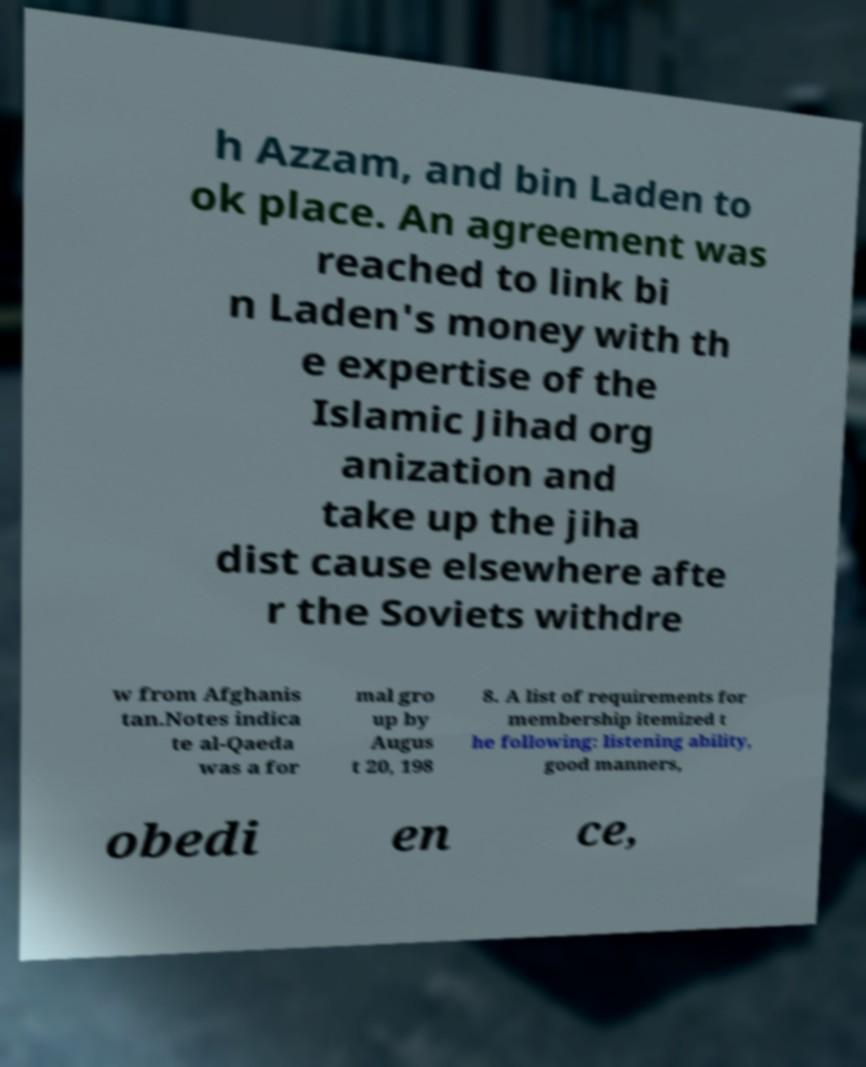For documentation purposes, I need the text within this image transcribed. Could you provide that? h Azzam, and bin Laden to ok place. An agreement was reached to link bi n Laden's money with th e expertise of the Islamic Jihad org anization and take up the jiha dist cause elsewhere afte r the Soviets withdre w from Afghanis tan.Notes indica te al-Qaeda was a for mal gro up by Augus t 20, 198 8. A list of requirements for membership itemized t he following: listening ability, good manners, obedi en ce, 